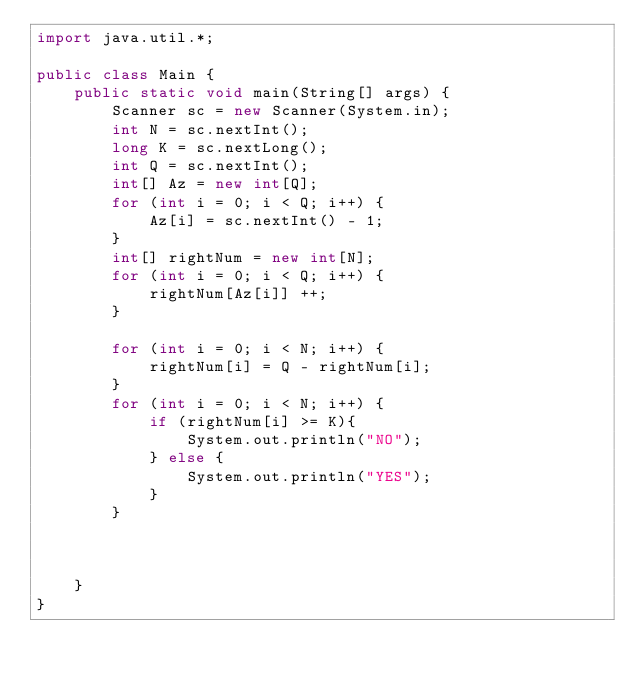<code> <loc_0><loc_0><loc_500><loc_500><_Java_>import java.util.*;

public class Main {
    public static void main(String[] args) {
        Scanner sc = new Scanner(System.in);
        int N = sc.nextInt();
        long K = sc.nextLong();
        int Q = sc.nextInt();
        int[] Az = new int[Q];
        for (int i = 0; i < Q; i++) {
            Az[i] = sc.nextInt() - 1;
        }
        int[] rightNum = new int[N];
        for (int i = 0; i < Q; i++) {
            rightNum[Az[i]] ++;
        }

        for (int i = 0; i < N; i++) {
            rightNum[i] = Q - rightNum[i];
        }
        for (int i = 0; i < N; i++) {
            if (rightNum[i] >= K){
                System.out.println("NO");
            } else {
                System.out.println("YES");
            }
        }



    }
}
</code> 